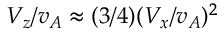<formula> <loc_0><loc_0><loc_500><loc_500>V _ { z } / v _ { A } \approx ( 3 / 4 ) ( V _ { x } / v _ { A } ) ^ { 2 }</formula> 